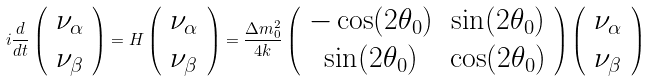<formula> <loc_0><loc_0><loc_500><loc_500>i \frac { d } { d t } \left ( \begin{array} { c } \nu _ { \alpha } \\ \nu _ { \beta } \end{array} \right ) = H \left ( \begin{array} { c } \nu _ { \alpha } \\ \nu _ { \beta } \end{array} \right ) = \frac { \Delta m _ { 0 } ^ { 2 } } { 4 k } \left ( \begin{array} { c c } - \cos ( 2 \theta _ { 0 } ) & \sin ( 2 \theta _ { 0 } ) \\ \sin ( 2 \theta _ { 0 } ) & \cos ( 2 \theta _ { 0 } ) \end{array} \right ) \left ( \begin{array} { c } \nu _ { \alpha } \\ \nu _ { \beta } \end{array} \right )</formula> 